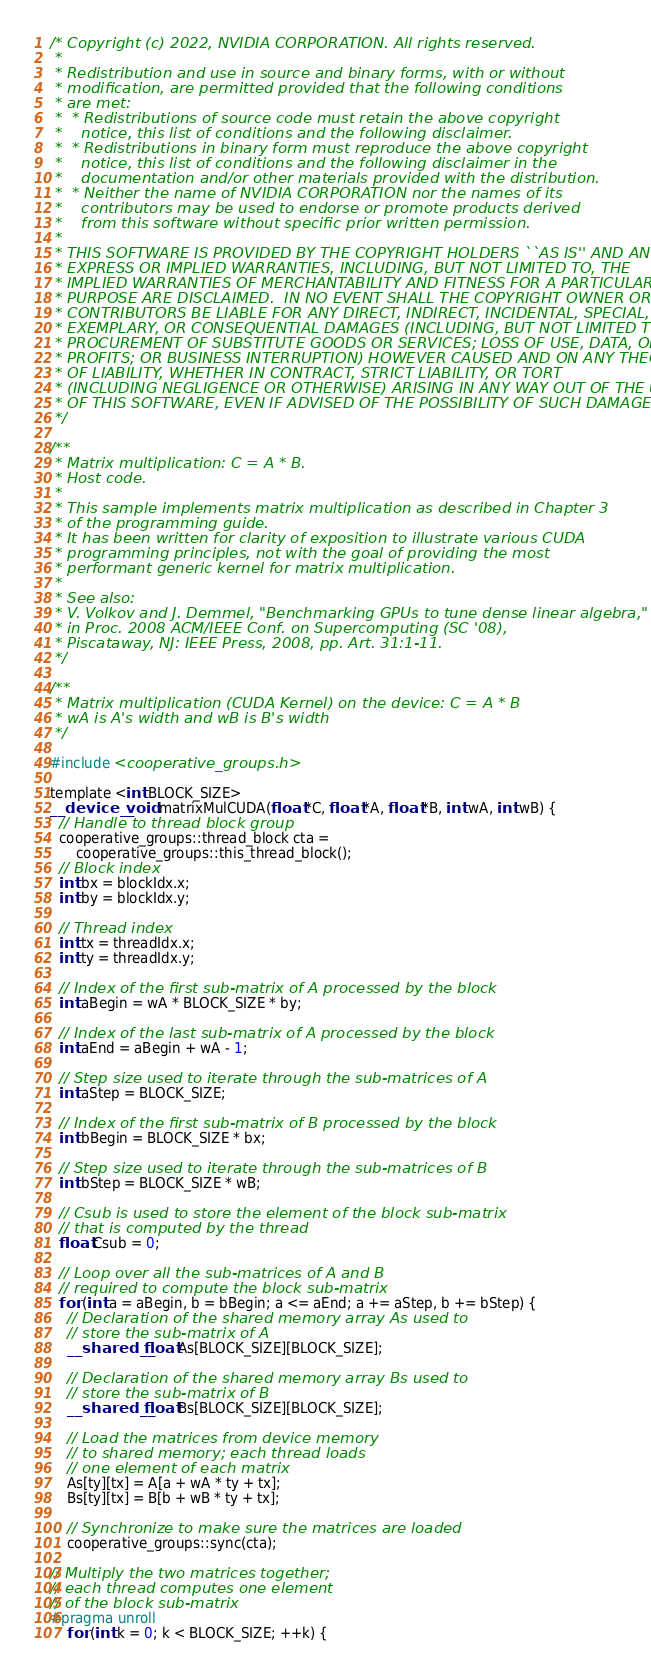Convert code to text. <code><loc_0><loc_0><loc_500><loc_500><_Cuda_>/* Copyright (c) 2022, NVIDIA CORPORATION. All rights reserved.
 *
 * Redistribution and use in source and binary forms, with or without
 * modification, are permitted provided that the following conditions
 * are met:
 *  * Redistributions of source code must retain the above copyright
 *    notice, this list of conditions and the following disclaimer.
 *  * Redistributions in binary form must reproduce the above copyright
 *    notice, this list of conditions and the following disclaimer in the
 *    documentation and/or other materials provided with the distribution.
 *  * Neither the name of NVIDIA CORPORATION nor the names of its
 *    contributors may be used to endorse or promote products derived
 *    from this software without specific prior written permission.
 *
 * THIS SOFTWARE IS PROVIDED BY THE COPYRIGHT HOLDERS ``AS IS'' AND ANY
 * EXPRESS OR IMPLIED WARRANTIES, INCLUDING, BUT NOT LIMITED TO, THE
 * IMPLIED WARRANTIES OF MERCHANTABILITY AND FITNESS FOR A PARTICULAR
 * PURPOSE ARE DISCLAIMED.  IN NO EVENT SHALL THE COPYRIGHT OWNER OR
 * CONTRIBUTORS BE LIABLE FOR ANY DIRECT, INDIRECT, INCIDENTAL, SPECIAL,
 * EXEMPLARY, OR CONSEQUENTIAL DAMAGES (INCLUDING, BUT NOT LIMITED TO,
 * PROCUREMENT OF SUBSTITUTE GOODS OR SERVICES; LOSS OF USE, DATA, OR
 * PROFITS; OR BUSINESS INTERRUPTION) HOWEVER CAUSED AND ON ANY THEORY
 * OF LIABILITY, WHETHER IN CONTRACT, STRICT LIABILITY, OR TORT
 * (INCLUDING NEGLIGENCE OR OTHERWISE) ARISING IN ANY WAY OUT OF THE USE
 * OF THIS SOFTWARE, EVEN IF ADVISED OF THE POSSIBILITY OF SUCH DAMAGE.
 */

/**
 * Matrix multiplication: C = A * B.
 * Host code.
 *
 * This sample implements matrix multiplication as described in Chapter 3
 * of the programming guide.
 * It has been written for clarity of exposition to illustrate various CUDA
 * programming principles, not with the goal of providing the most
 * performant generic kernel for matrix multiplication.
 *
 * See also:
 * V. Volkov and J. Demmel, "Benchmarking GPUs to tune dense linear algebra,"
 * in Proc. 2008 ACM/IEEE Conf. on Supercomputing (SC '08),
 * Piscataway, NJ: IEEE Press, 2008, pp. Art. 31:1-11.
 */

/**
 * Matrix multiplication (CUDA Kernel) on the device: C = A * B
 * wA is A's width and wB is B's width
 */

#include <cooperative_groups.h>

template <int BLOCK_SIZE>
__device__ void matrixMulCUDA(float *C, float *A, float *B, int wA, int wB) {
  // Handle to thread block group
  cooperative_groups::thread_block cta =
      cooperative_groups::this_thread_block();
  // Block index
  int bx = blockIdx.x;
  int by = blockIdx.y;

  // Thread index
  int tx = threadIdx.x;
  int ty = threadIdx.y;

  // Index of the first sub-matrix of A processed by the block
  int aBegin = wA * BLOCK_SIZE * by;

  // Index of the last sub-matrix of A processed by the block
  int aEnd = aBegin + wA - 1;

  // Step size used to iterate through the sub-matrices of A
  int aStep = BLOCK_SIZE;

  // Index of the first sub-matrix of B processed by the block
  int bBegin = BLOCK_SIZE * bx;

  // Step size used to iterate through the sub-matrices of B
  int bStep = BLOCK_SIZE * wB;

  // Csub is used to store the element of the block sub-matrix
  // that is computed by the thread
  float Csub = 0;

  // Loop over all the sub-matrices of A and B
  // required to compute the block sub-matrix
  for (int a = aBegin, b = bBegin; a <= aEnd; a += aStep, b += bStep) {
    // Declaration of the shared memory array As used to
    // store the sub-matrix of A
    __shared__ float As[BLOCK_SIZE][BLOCK_SIZE];

    // Declaration of the shared memory array Bs used to
    // store the sub-matrix of B
    __shared__ float Bs[BLOCK_SIZE][BLOCK_SIZE];

    // Load the matrices from device memory
    // to shared memory; each thread loads
    // one element of each matrix
    As[ty][tx] = A[a + wA * ty + tx];
    Bs[ty][tx] = B[b + wB * ty + tx];

    // Synchronize to make sure the matrices are loaded
    cooperative_groups::sync(cta);

// Multiply the two matrices together;
// each thread computes one element
// of the block sub-matrix
#pragma unroll
    for (int k = 0; k < BLOCK_SIZE; ++k) {</code> 